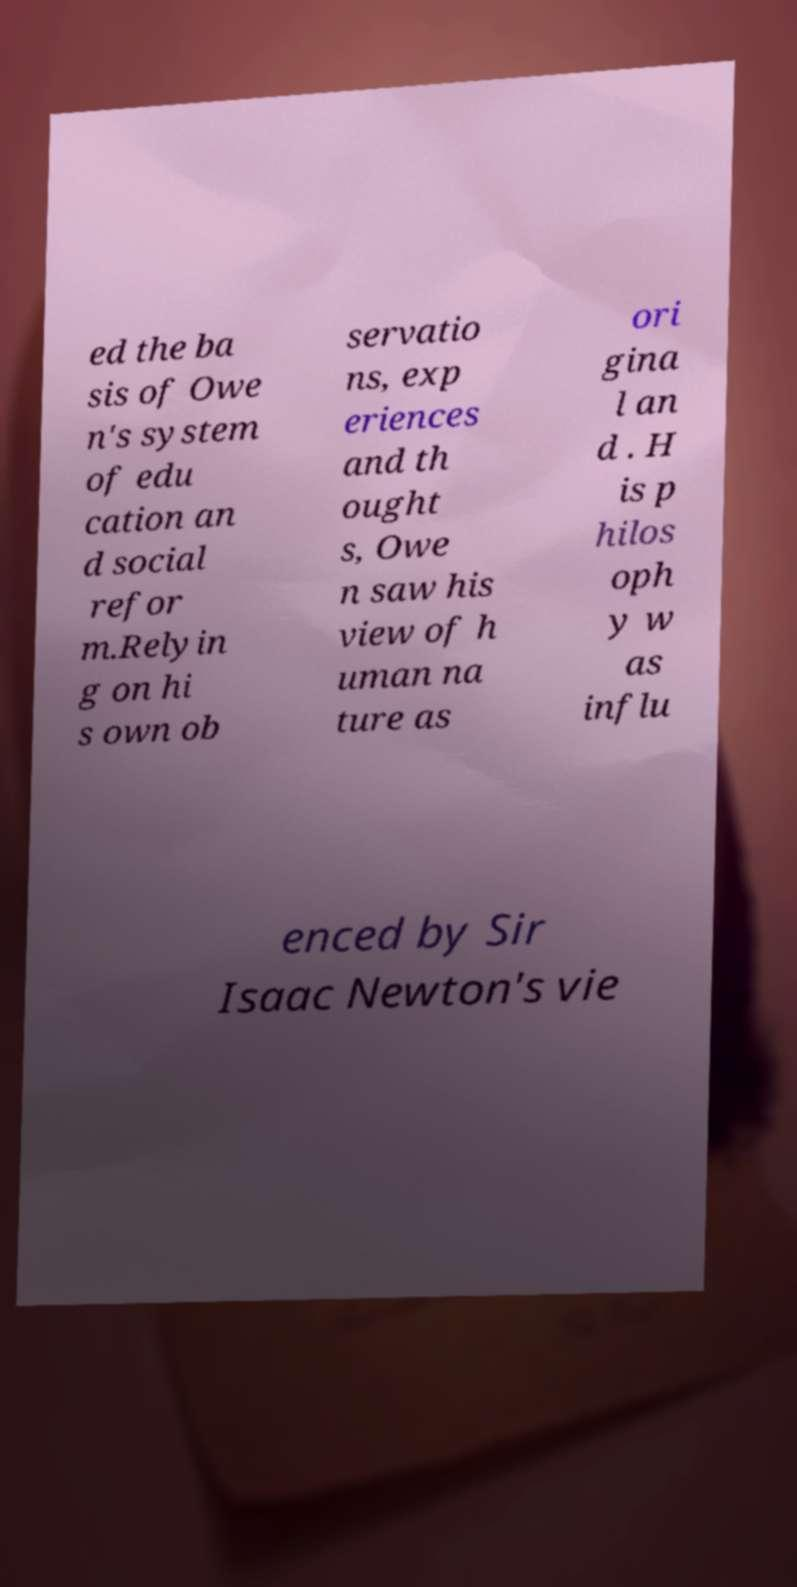Please read and relay the text visible in this image. What does it say? ed the ba sis of Owe n's system of edu cation an d social refor m.Relyin g on hi s own ob servatio ns, exp eriences and th ought s, Owe n saw his view of h uman na ture as ori gina l an d . H is p hilos oph y w as influ enced by Sir Isaac Newton's vie 